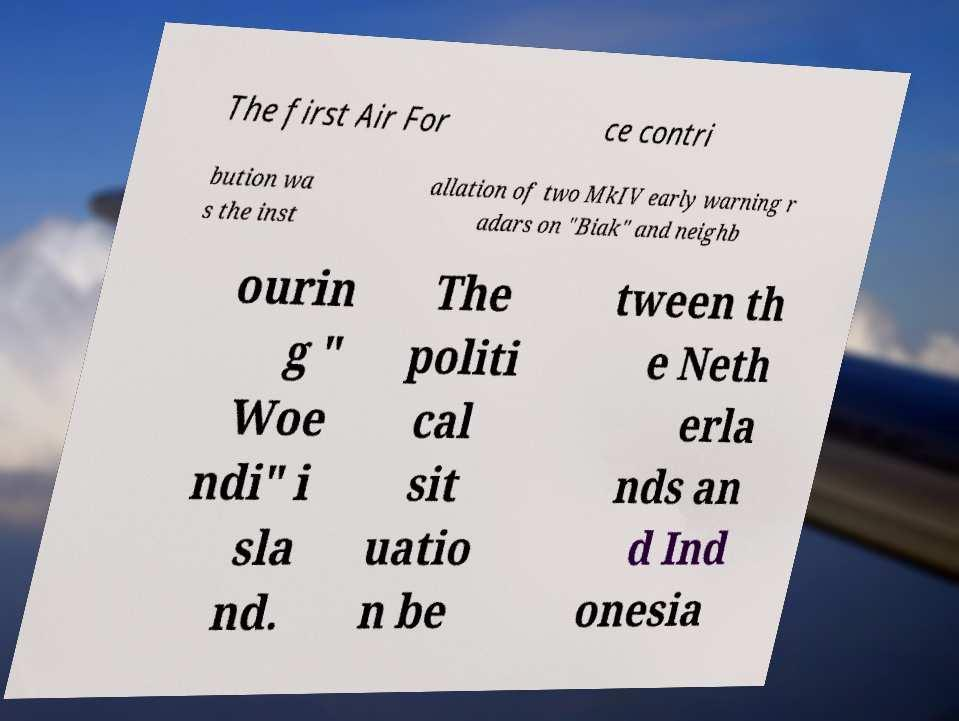Please identify and transcribe the text found in this image. The first Air For ce contri bution wa s the inst allation of two MkIV early warning r adars on "Biak" and neighb ourin g " Woe ndi" i sla nd. The politi cal sit uatio n be tween th e Neth erla nds an d Ind onesia 